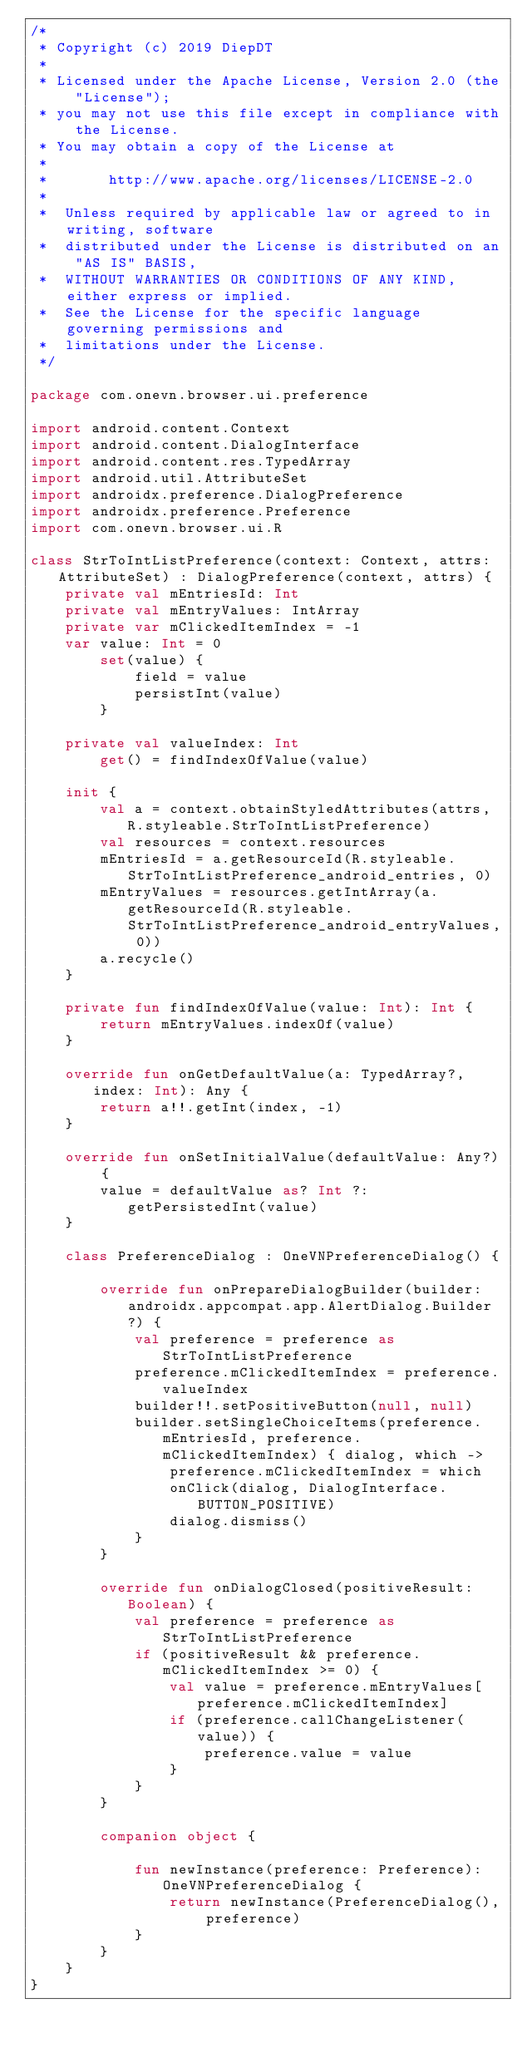<code> <loc_0><loc_0><loc_500><loc_500><_Kotlin_>/*
 * Copyright (c) 2019 DiepDT
 *
 * Licensed under the Apache License, Version 2.0 (the "License");
 * you may not use this file except in compliance with the License.
 * You may obtain a copy of the License at
 *
 *       http://www.apache.org/licenses/LICENSE-2.0
 *
 *  Unless required by applicable law or agreed to in writing, software
 *  distributed under the License is distributed on an "AS IS" BASIS,
 *  WITHOUT WARRANTIES OR CONDITIONS OF ANY KIND, either express or implied.
 *  See the License for the specific language governing permissions and
 *  limitations under the License.
 */

package com.onevn.browser.ui.preference

import android.content.Context
import android.content.DialogInterface
import android.content.res.TypedArray
import android.util.AttributeSet
import androidx.preference.DialogPreference
import androidx.preference.Preference
import com.onevn.browser.ui.R

class StrToIntListPreference(context: Context, attrs: AttributeSet) : DialogPreference(context, attrs) {
    private val mEntriesId: Int
    private val mEntryValues: IntArray
    private var mClickedItemIndex = -1
    var value: Int = 0
        set(value) {
            field = value
            persistInt(value)
        }

    private val valueIndex: Int
        get() = findIndexOfValue(value)

    init {
        val a = context.obtainStyledAttributes(attrs, R.styleable.StrToIntListPreference)
        val resources = context.resources
        mEntriesId = a.getResourceId(R.styleable.StrToIntListPreference_android_entries, 0)
        mEntryValues = resources.getIntArray(a.getResourceId(R.styleable.StrToIntListPreference_android_entryValues, 0))
        a.recycle()
    }

    private fun findIndexOfValue(value: Int): Int {
        return mEntryValues.indexOf(value)
    }

    override fun onGetDefaultValue(a: TypedArray?, index: Int): Any {
        return a!!.getInt(index, -1)
    }

    override fun onSetInitialValue(defaultValue: Any?) {
        value = defaultValue as? Int ?: getPersistedInt(value)
    }

    class PreferenceDialog : OneVNPreferenceDialog() {

        override fun onPrepareDialogBuilder(builder: androidx.appcompat.app.AlertDialog.Builder?) {
            val preference = preference as StrToIntListPreference
            preference.mClickedItemIndex = preference.valueIndex
            builder!!.setPositiveButton(null, null)
            builder.setSingleChoiceItems(preference.mEntriesId, preference.mClickedItemIndex) { dialog, which ->
                preference.mClickedItemIndex = which
                onClick(dialog, DialogInterface.BUTTON_POSITIVE)
                dialog.dismiss()
            }
        }

        override fun onDialogClosed(positiveResult: Boolean) {
            val preference = preference as StrToIntListPreference
            if (positiveResult && preference.mClickedItemIndex >= 0) {
                val value = preference.mEntryValues[preference.mClickedItemIndex]
                if (preference.callChangeListener(value)) {
                    preference.value = value
                }
            }
        }

        companion object {

            fun newInstance(preference: Preference): OneVNPreferenceDialog {
                return newInstance(PreferenceDialog(), preference)
            }
        }
    }
}
</code> 